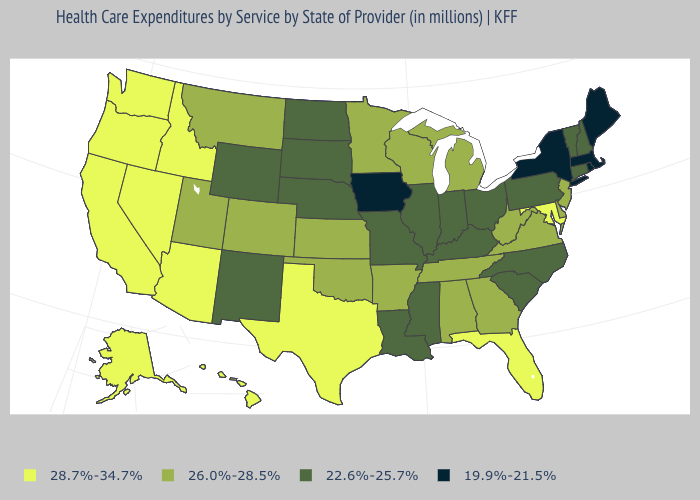Name the states that have a value in the range 22.6%-25.7%?
Short answer required. Connecticut, Illinois, Indiana, Kentucky, Louisiana, Mississippi, Missouri, Nebraska, New Hampshire, New Mexico, North Carolina, North Dakota, Ohio, Pennsylvania, South Carolina, South Dakota, Vermont, Wyoming. Does Arizona have a higher value than Michigan?
Quick response, please. Yes. What is the value of Mississippi?
Quick response, please. 22.6%-25.7%. Name the states that have a value in the range 26.0%-28.5%?
Answer briefly. Alabama, Arkansas, Colorado, Delaware, Georgia, Kansas, Michigan, Minnesota, Montana, New Jersey, Oklahoma, Tennessee, Utah, Virginia, West Virginia, Wisconsin. What is the value of North Carolina?
Concise answer only. 22.6%-25.7%. Name the states that have a value in the range 22.6%-25.7%?
Be succinct. Connecticut, Illinois, Indiana, Kentucky, Louisiana, Mississippi, Missouri, Nebraska, New Hampshire, New Mexico, North Carolina, North Dakota, Ohio, Pennsylvania, South Carolina, South Dakota, Vermont, Wyoming. What is the value of Kentucky?
Answer briefly. 22.6%-25.7%. Which states hav the highest value in the MidWest?
Be succinct. Kansas, Michigan, Minnesota, Wisconsin. Among the states that border Nebraska , which have the lowest value?
Give a very brief answer. Iowa. Does the map have missing data?
Answer briefly. No. What is the highest value in the West ?
Short answer required. 28.7%-34.7%. Name the states that have a value in the range 22.6%-25.7%?
Short answer required. Connecticut, Illinois, Indiana, Kentucky, Louisiana, Mississippi, Missouri, Nebraska, New Hampshire, New Mexico, North Carolina, North Dakota, Ohio, Pennsylvania, South Carolina, South Dakota, Vermont, Wyoming. Name the states that have a value in the range 22.6%-25.7%?
Keep it brief. Connecticut, Illinois, Indiana, Kentucky, Louisiana, Mississippi, Missouri, Nebraska, New Hampshire, New Mexico, North Carolina, North Dakota, Ohio, Pennsylvania, South Carolina, South Dakota, Vermont, Wyoming. What is the highest value in the Northeast ?
Concise answer only. 26.0%-28.5%. What is the value of Illinois?
Write a very short answer. 22.6%-25.7%. 